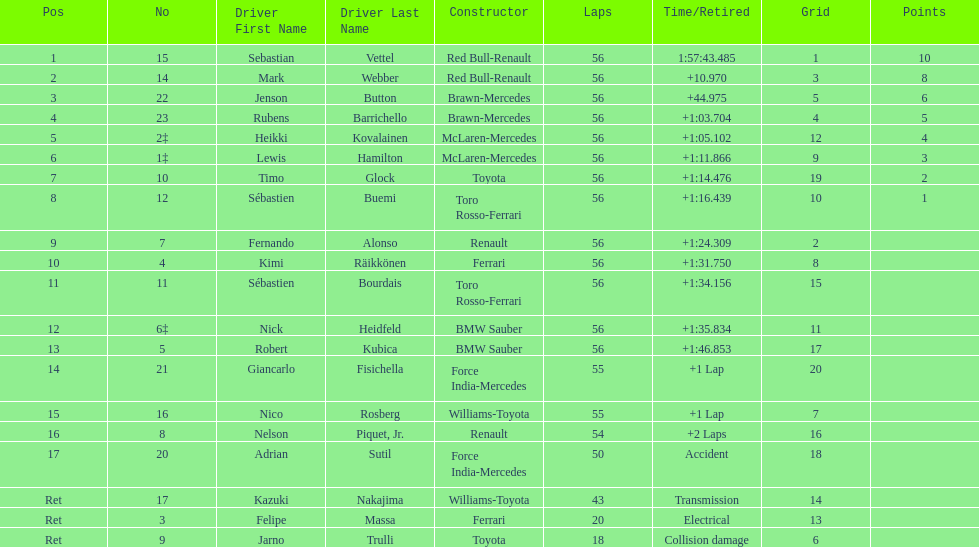What is the total number of drivers on the list? 20. 